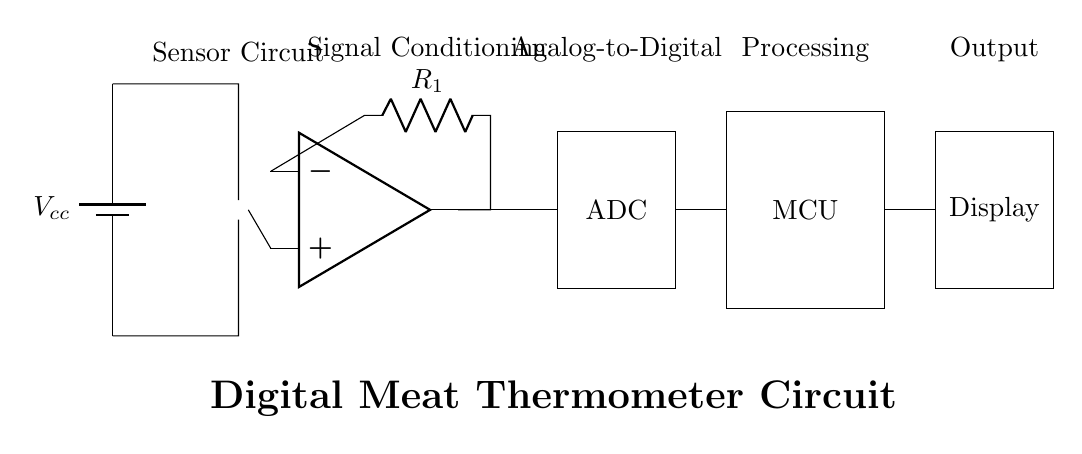What is the main function of the temperature sensor in this circuit? The main function of the temperature sensor, indicated as a thermistor in the diagram, is to measure the temperature of the meat, translating it into a change in resistance that can be processed by the circuit.
Answer: Temperature measurement What component amplifies the signal from the temperature sensor? The component that amplifies the signal is labeled as an operational amplifier in the circuit diagram, which enhances the weak signal from the temperature sensor for further processing.
Answer: Operational amplifier How is the output from the ADC connected to the microcontroller? The output from the ADC is connected to the microcontroller by a direct line shown in the diagram, indicating the flow of digital data from the analog-to-digital converter to the processing unit.
Answer: Direct connection Which component is responsible for converting the analog signal to a digital signal? The component responsible for converting the analog signal to a digital signal is the ADC, as indicated in the circuit diagram, performing the crucial function of transforming the amplified signal for digital processing.
Answer: ADC What role does the display play in the circuit? The display serves the function of showing the measured temperature to the user, providing a visual output that reflects the processed data from the microcontroller.
Answer: Visual output What type of sensor is used in this circuit? The type of sensor used in this circuit is a thermistor, which is a temperature-sensitive resistor that changes its resistance with temperature variations.
Answer: Thermistor What is the purpose of the label "Signal Conditioning" in the circuit? The label "Signal Conditioning" indicates the section of the circuit where the signal from the temperature sensor is amplified and adjusted to ensure it is suitable for further processing by the ADC, improving accuracy and reliability.
Answer: Amplification and adjustment 